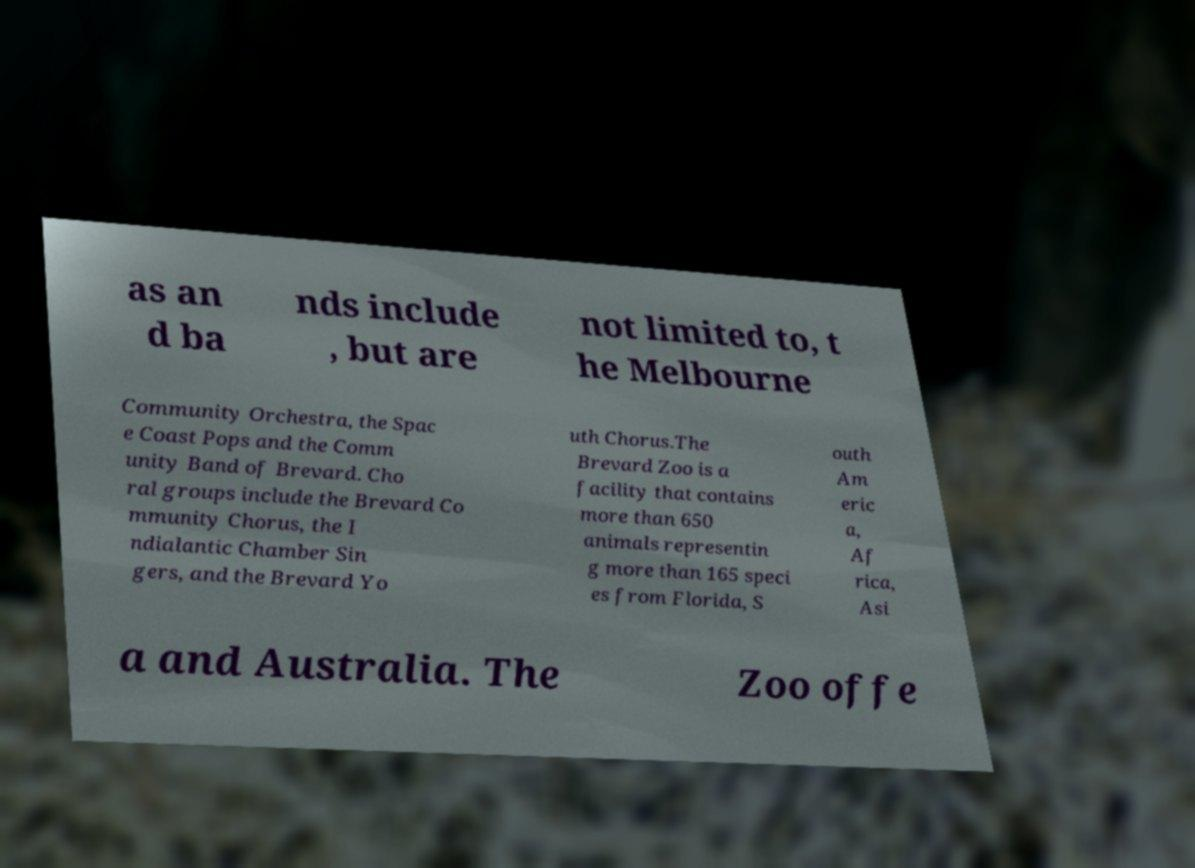Can you read and provide the text displayed in the image?This photo seems to have some interesting text. Can you extract and type it out for me? as an d ba nds include , but are not limited to, t he Melbourne Community Orchestra, the Spac e Coast Pops and the Comm unity Band of Brevard. Cho ral groups include the Brevard Co mmunity Chorus, the I ndialantic Chamber Sin gers, and the Brevard Yo uth Chorus.The Brevard Zoo is a facility that contains more than 650 animals representin g more than 165 speci es from Florida, S outh Am eric a, Af rica, Asi a and Australia. The Zoo offe 